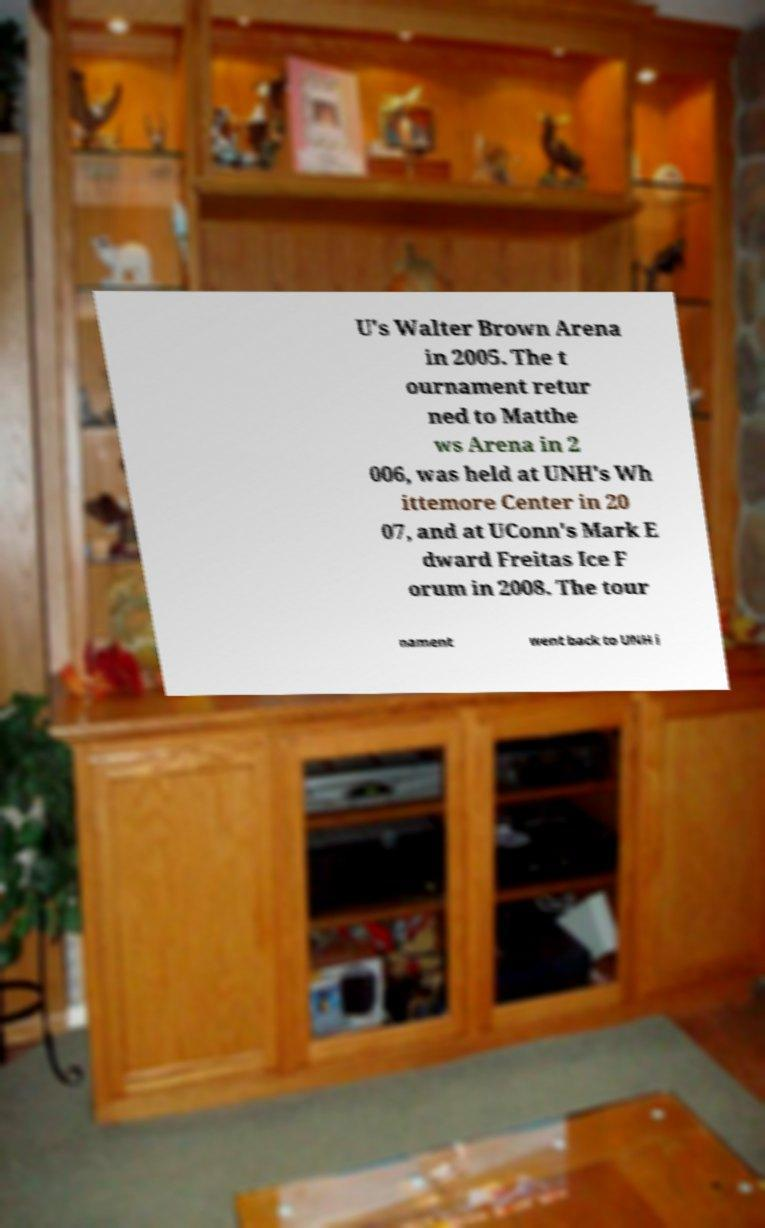Can you read and provide the text displayed in the image?This photo seems to have some interesting text. Can you extract and type it out for me? U's Walter Brown Arena in 2005. The t ournament retur ned to Matthe ws Arena in 2 006, was held at UNH's Wh ittemore Center in 20 07, and at UConn's Mark E dward Freitas Ice F orum in 2008. The tour nament went back to UNH i 